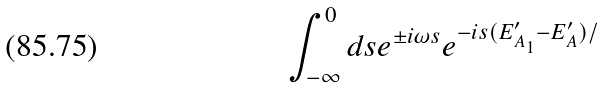Convert formula to latex. <formula><loc_0><loc_0><loc_500><loc_500>\int _ { - \infty } ^ { 0 } d s e ^ { \pm i \omega s } e ^ { - i s ( E _ { A _ { 1 } } ^ { \prime } - E _ { A } ^ { \prime } ) / }</formula> 